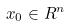<formula> <loc_0><loc_0><loc_500><loc_500>x _ { 0 } \in R ^ { n }</formula> 